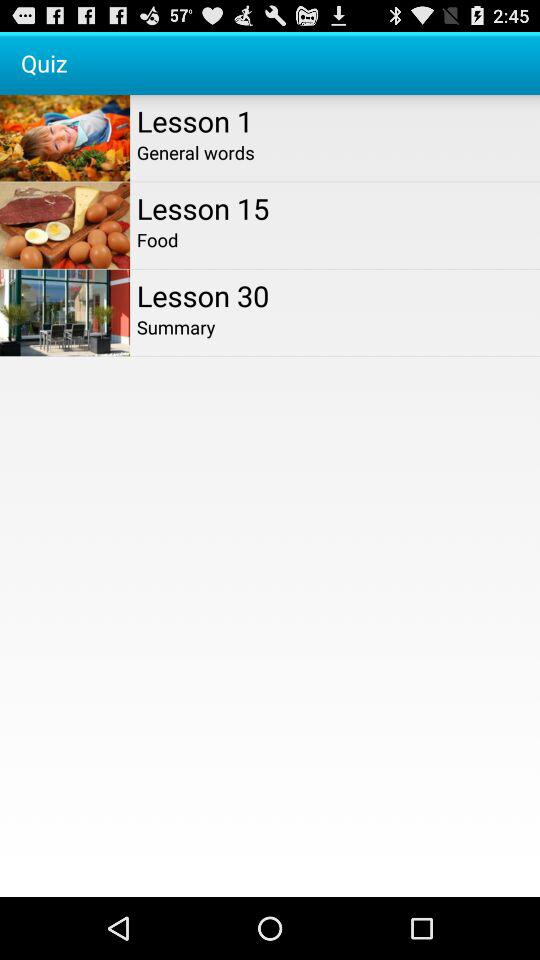Which lesson is the summary given in? The summary is given in lesson 30. 